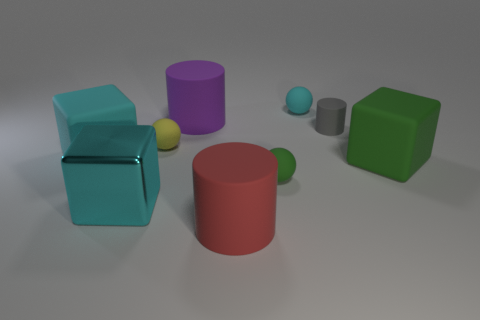There is another big thing that is the same color as the big metal thing; what shape is it?
Keep it short and to the point. Cube. How many other objects are there of the same color as the big metal object?
Your answer should be very brief. 2. Are there more cyan metal blocks to the right of the big cyan metallic cube than gray things?
Offer a very short reply. No. Do the purple object and the red thing have the same material?
Provide a short and direct response. Yes. What number of objects are rubber cubes that are left of the tiny cyan rubber ball or big red rubber things?
Provide a short and direct response. 2. What number of other things are there of the same size as the purple rubber cylinder?
Keep it short and to the point. 4. Are there an equal number of purple rubber objects that are in front of the tiny gray thing and yellow matte objects that are to the left of the tiny cyan rubber ball?
Your answer should be very brief. No. The large shiny object that is the same shape as the large cyan matte thing is what color?
Offer a very short reply. Cyan. Are there any other things that are the same shape as the small yellow rubber object?
Provide a succinct answer. Yes. There is a sphere that is to the left of the large purple rubber thing; is it the same color as the tiny rubber cylinder?
Make the answer very short. No. 